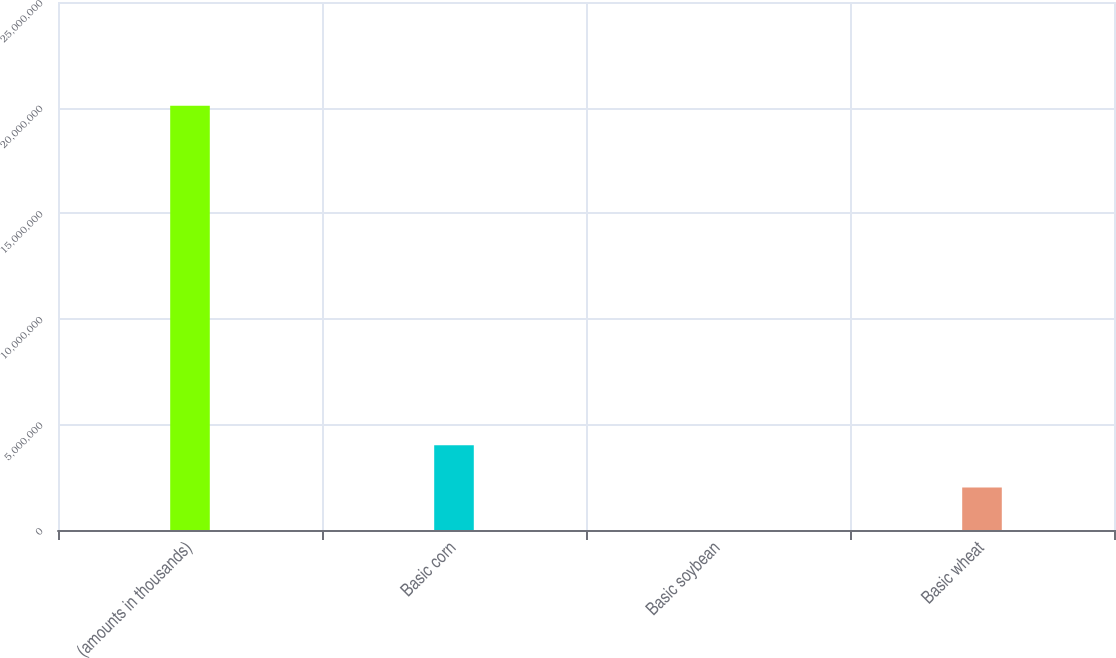Convert chart. <chart><loc_0><loc_0><loc_500><loc_500><bar_chart><fcel>(amounts in thousands)<fcel>Basic corn<fcel>Basic soybean<fcel>Basic wheat<nl><fcel>2.0092e+07<fcel>4.0184e+06<fcel>1<fcel>2.0092e+06<nl></chart> 